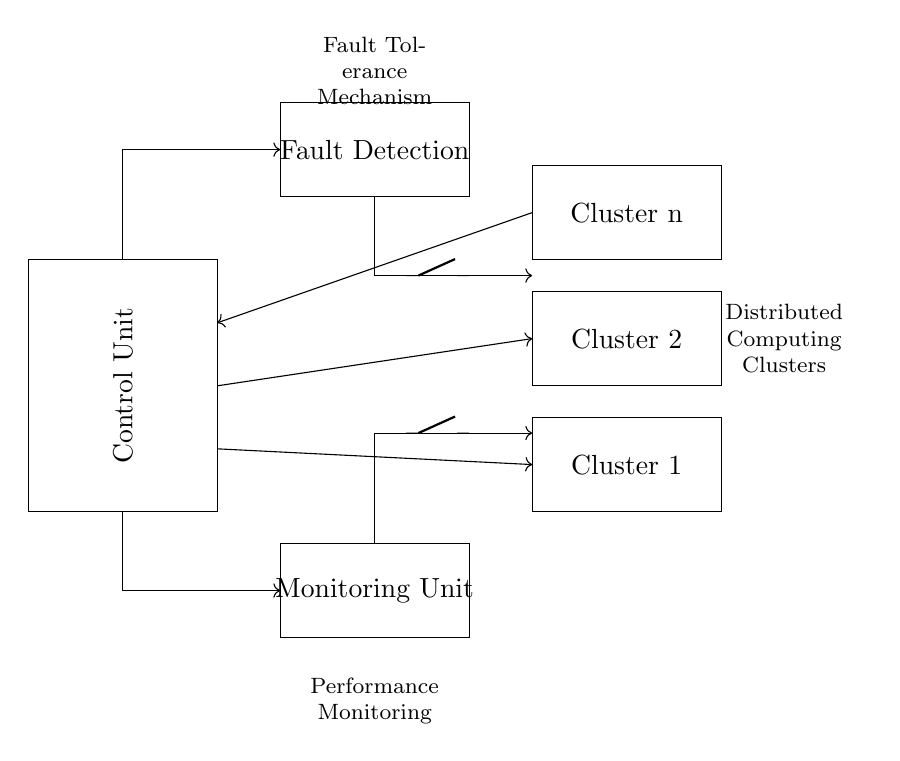What is the main control unit? The main control unit is labeled simply as "Control Unit" in the diagram. It is located at the far left, providing the primary function of coordinating the operation of the connected components.
Answer: Control Unit How many distributed computing clusters are shown? The diagram displays three distributed computing clusters, as indicated by the labeled rectangles that read "Cluster 1", "Cluster 2", and "Cluster n".
Answer: Three What role does the fault detection unit play? The fault detection unit is responsible for identifying issues within the distributed computing clusters, as suggested by the label "Fault Detection" above the unit. This unit interacts with the main control unit to facilitate fault tolerance.
Answer: Fault detection What kind of feedback loops are present in this circuit? There are feedback loops connecting the fault detection and monitoring units back to the main control unit, indicated by the arrows returning to these components. This suggests a mechanism for continuous monitoring and control adjustments in response to detected faults.
Answer: Feedback loops Which units are connected to the monitoring unit? The monitoring unit receives input connections from the fault detection unit as well as a connection to the distributed computing clusters, highlighting its role in maintaining oversight of the system's performance.
Answer: Fault Detection, Distributed Computing Clusters What mechanism is highlighted in the circuit? The circuit highlights a fault tolerance mechanism, as described in the label situated above the fault detection unit. This mechanism ensures operational reliability in the event of component failures within the clusters.
Answer: Fault Tolerance Mechanism Which unit manages performance monitoring? The monitoring unit is specifically designated for overseeing the performance of the distributed computing clusters, which is indicated by the label "Monitoring Unit" in the diagram below it.
Answer: Monitoring Unit 